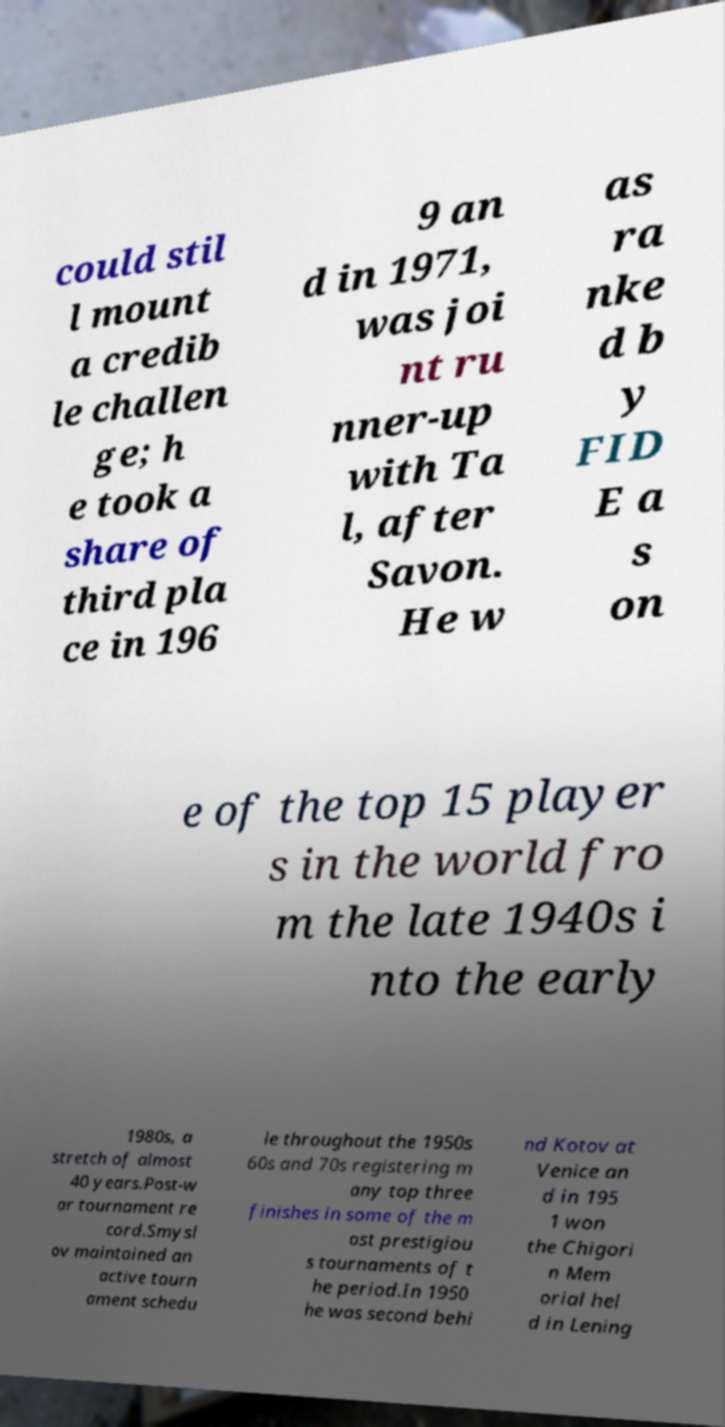Could you assist in decoding the text presented in this image and type it out clearly? could stil l mount a credib le challen ge; h e took a share of third pla ce in 196 9 an d in 1971, was joi nt ru nner-up with Ta l, after Savon. He w as ra nke d b y FID E a s on e of the top 15 player s in the world fro m the late 1940s i nto the early 1980s, a stretch of almost 40 years.Post-w ar tournament re cord.Smysl ov maintained an active tourn ament schedu le throughout the 1950s 60s and 70s registering m any top three finishes in some of the m ost prestigiou s tournaments of t he period.In 1950 he was second behi nd Kotov at Venice an d in 195 1 won the Chigori n Mem orial hel d in Lening 